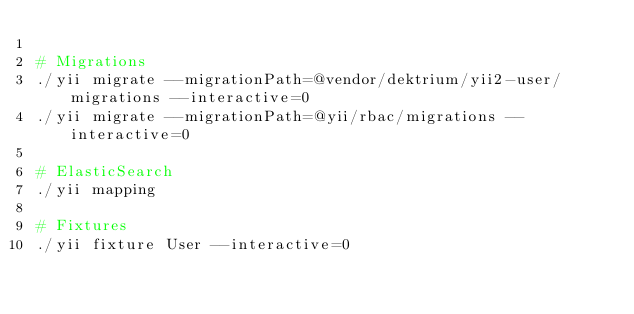<code> <loc_0><loc_0><loc_500><loc_500><_Bash_>
# Migrations
./yii migrate --migrationPath=@vendor/dektrium/yii2-user/migrations --interactive=0
./yii migrate --migrationPath=@yii/rbac/migrations --interactive=0

# ElasticSearch
./yii mapping

# Fixtures
./yii fixture User --interactive=0
</code> 